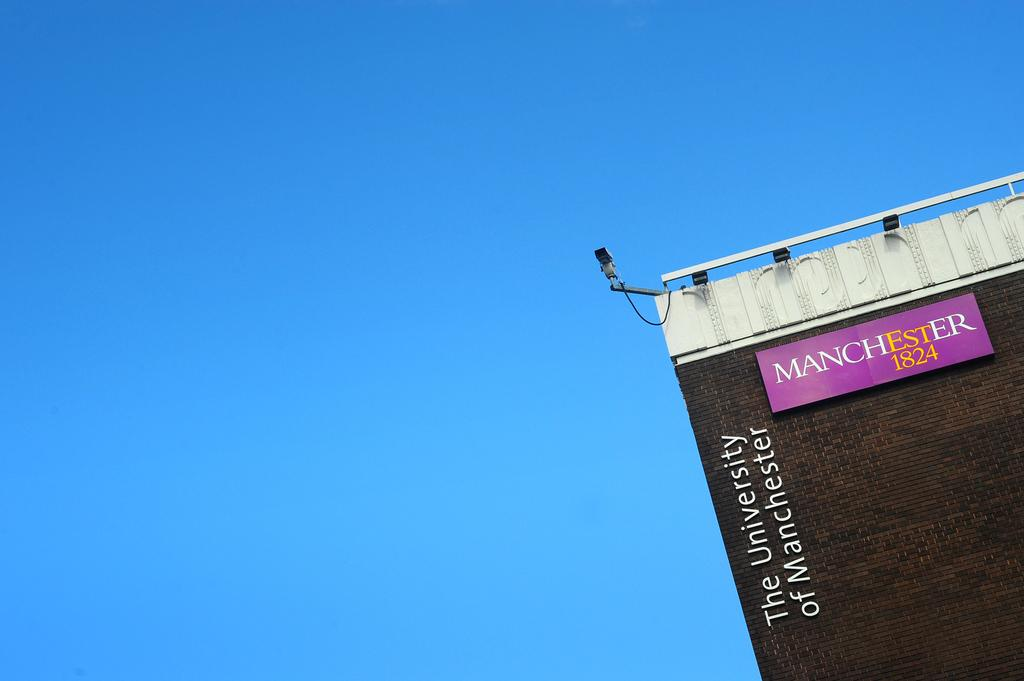<image>
Relay a brief, clear account of the picture shown. A building saying the university of manchester on it 